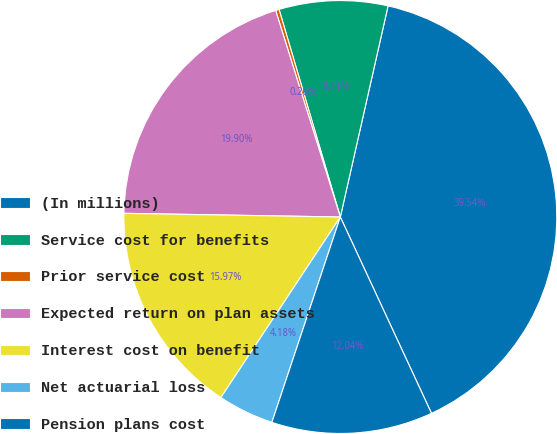<chart> <loc_0><loc_0><loc_500><loc_500><pie_chart><fcel>(In millions)<fcel>Service cost for benefits<fcel>Prior service cost<fcel>Expected return on plan assets<fcel>Interest cost on benefit<fcel>Net actuarial loss<fcel>Pension plans cost<nl><fcel>39.54%<fcel>8.11%<fcel>0.26%<fcel>19.9%<fcel>15.97%<fcel>4.18%<fcel>12.04%<nl></chart> 